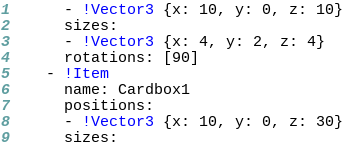<code> <loc_0><loc_0><loc_500><loc_500><_YAML_>      - !Vector3 {x: 10, y: 0, z: 10}
      sizes: 
      - !Vector3 {x: 4, y: 2, z: 4}
      rotations: [90]
    - !Item 
      name: Cardbox1 
      positions: 
      - !Vector3 {x: 10, y: 0, z: 30}
      sizes: </code> 